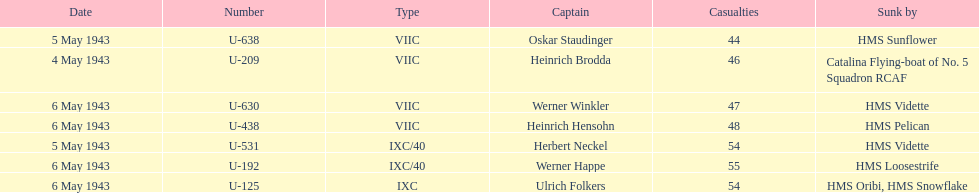On what date did at least 55 fatalities occur? 6 May 1943. 